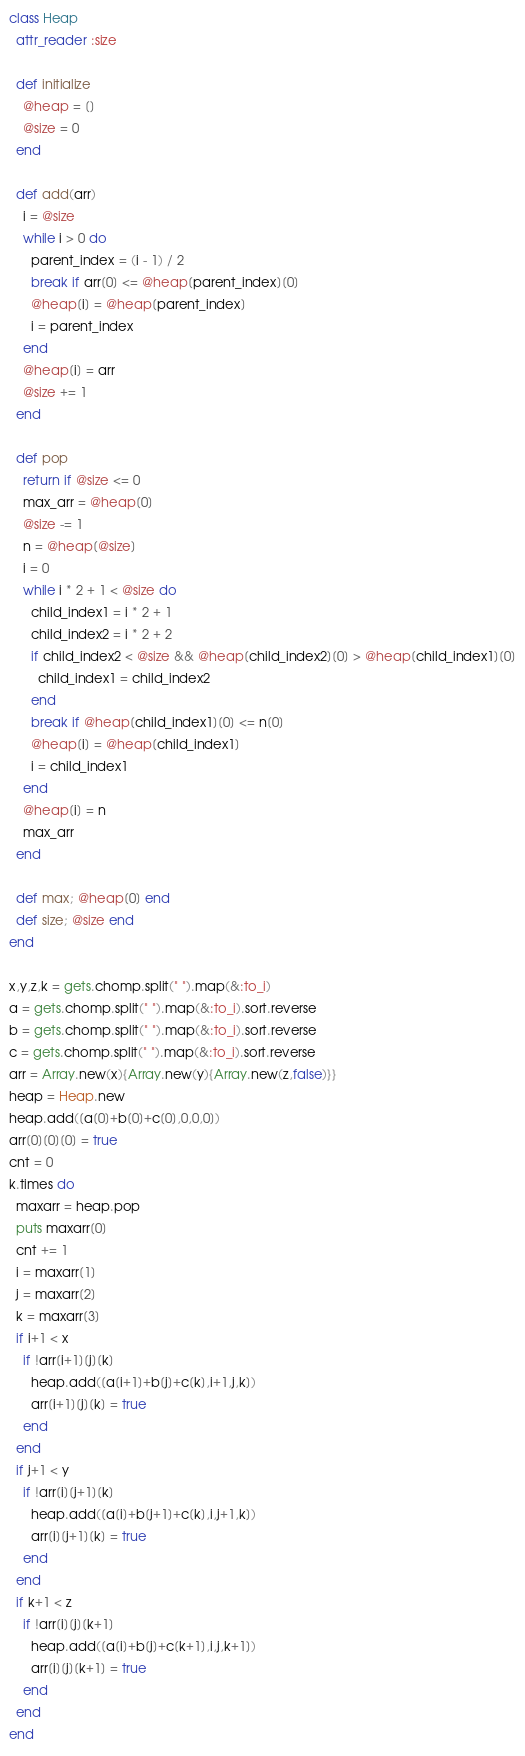Convert code to text. <code><loc_0><loc_0><loc_500><loc_500><_Ruby_>class Heap
  attr_reader :size

  def initialize
    @heap = []
    @size = 0
  end

  def add(arr)
    i = @size
    while i > 0 do
      parent_index = (i - 1) / 2
      break if arr[0] <= @heap[parent_index][0]
      @heap[i] = @heap[parent_index]
      i = parent_index
    end
    @heap[i] = arr
    @size += 1
  end

  def pop
    return if @size <= 0
    max_arr = @heap[0]
    @size -= 1
    n = @heap[@size]
    i = 0
    while i * 2 + 1 < @size do
      child_index1 = i * 2 + 1
      child_index2 = i * 2 + 2
      if child_index2 < @size && @heap[child_index2][0] > @heap[child_index1][0]
        child_index1 = child_index2
      end
      break if @heap[child_index1][0] <= n[0]
      @heap[i] = @heap[child_index1]
      i = child_index1
    end
    @heap[i] = n
    max_arr
  end

  def max; @heap[0] end
  def size; @size end
end

x,y,z,k = gets.chomp.split(" ").map(&:to_i)
a = gets.chomp.split(" ").map(&:to_i).sort.reverse
b = gets.chomp.split(" ").map(&:to_i).sort.reverse
c = gets.chomp.split(" ").map(&:to_i).sort.reverse
arr = Array.new(x){Array.new(y){Array.new(z,false)}}
heap = Heap.new
heap.add([a[0]+b[0]+c[0],0,0,0])
arr[0][0][0] = true
cnt = 0
k.times do
  maxarr = heap.pop
  puts maxarr[0]
  cnt += 1
  i = maxarr[1]
  j = maxarr[2]
  k = maxarr[3]
  if i+1 < x
    if !arr[i+1][j][k]
      heap.add([a[i+1]+b[j]+c[k],i+1,j,k])
      arr[i+1][j][k] = true
    end
  end
  if j+1 < y
    if !arr[i][j+1][k]
      heap.add([a[i]+b[j+1]+c[k],i,j+1,k])
      arr[i][j+1][k] = true
    end
  end
  if k+1 < z
    if !arr[i][j][k+1]
      heap.add([a[i]+b[j]+c[k+1],i,j,k+1])
      arr[i][j][k+1] = true
    end
  end
end</code> 